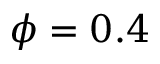Convert formula to latex. <formula><loc_0><loc_0><loc_500><loc_500>\phi = 0 . 4</formula> 